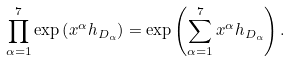<formula> <loc_0><loc_0><loc_500><loc_500>\prod _ { \alpha = 1 } ^ { 7 } \exp \left ( x ^ { \alpha } h _ { D _ { \alpha } } \right ) = \exp \left ( \sum _ { \alpha = 1 } ^ { 7 } x ^ { \alpha } h _ { D _ { \alpha } } \right ) .</formula> 